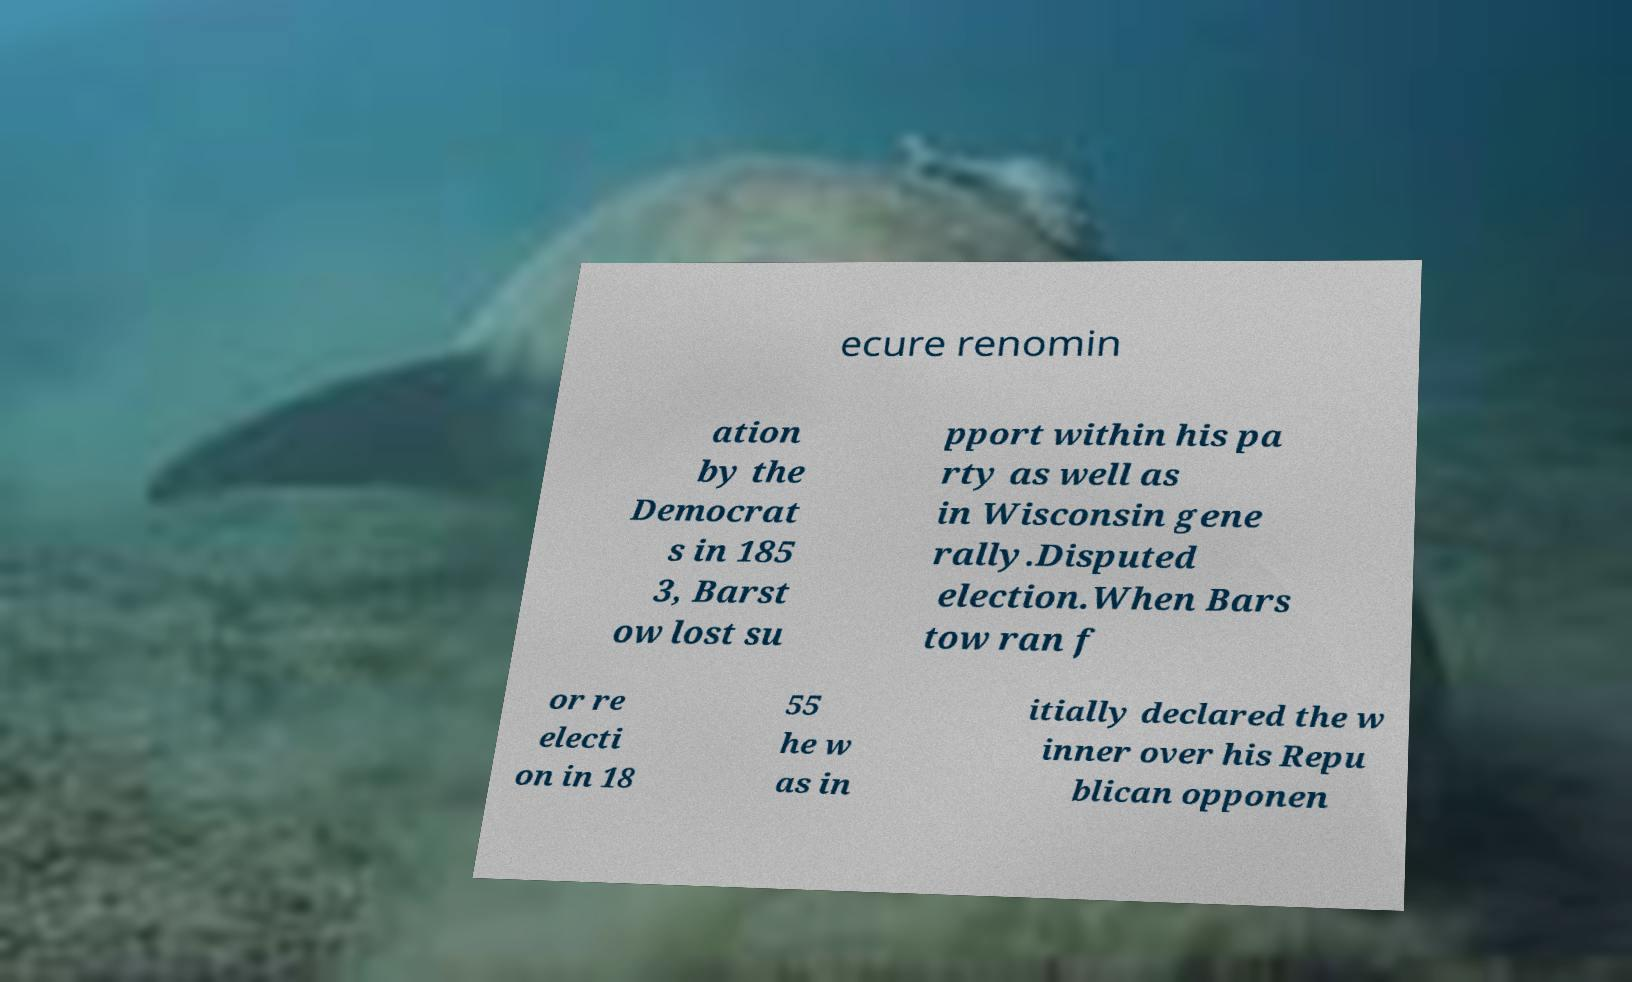Can you accurately transcribe the text from the provided image for me? ecure renomin ation by the Democrat s in 185 3, Barst ow lost su pport within his pa rty as well as in Wisconsin gene rally.Disputed election.When Bars tow ran f or re electi on in 18 55 he w as in itially declared the w inner over his Repu blican opponen 